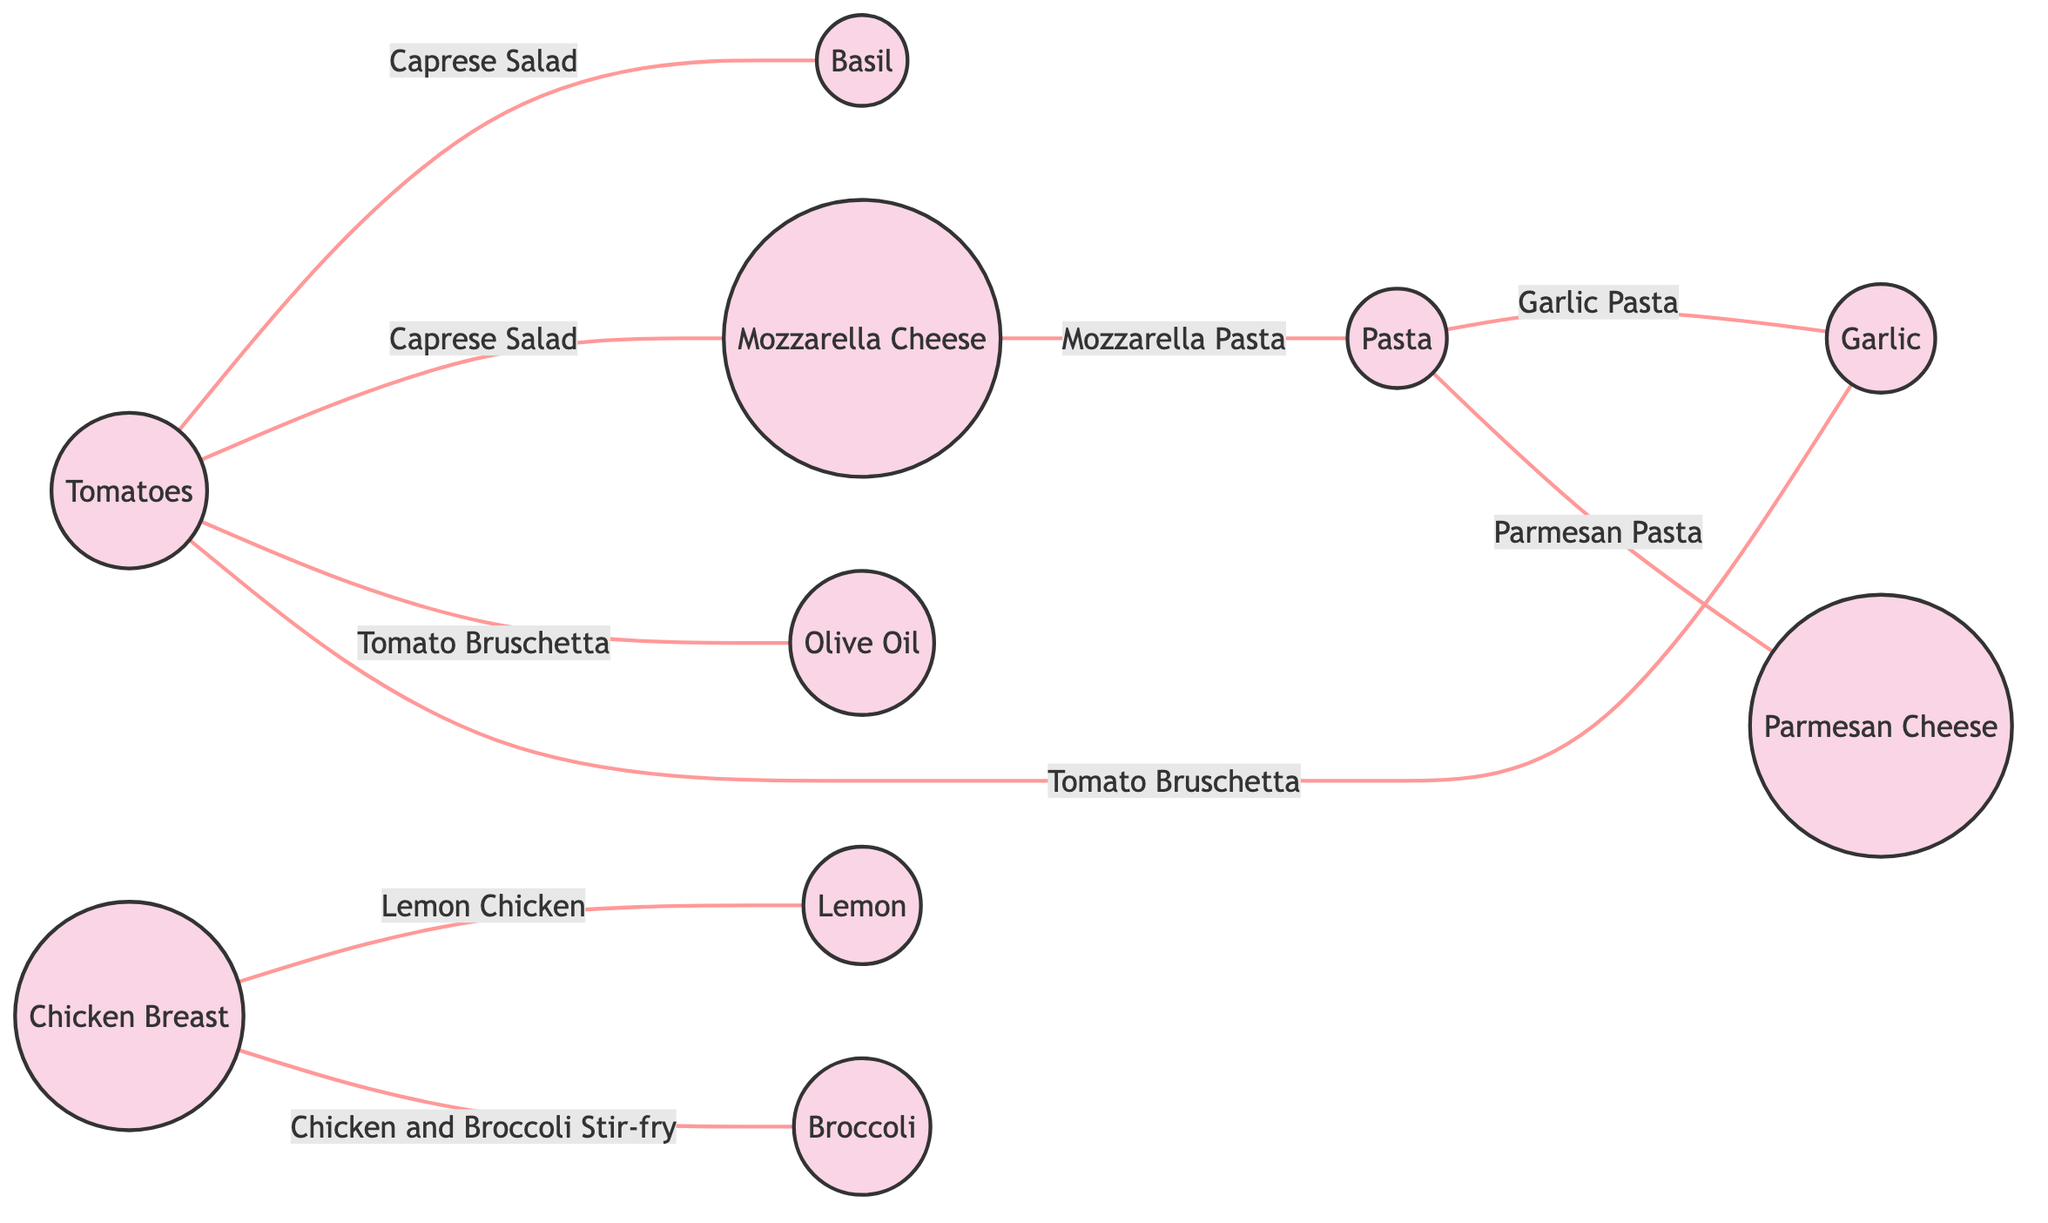What ingredient is used in both Caprese Salad and Tomato Bruschetta? By examining the edges connected to the single ingredient nodes "Caprese Salad" and "Tomato Bruschetta," we can identify that "Tomatoes" is common in both dishes as it connects to both dish nodes.
Answer: Tomatoes How many dishes are listed in the diagram? The edges represent dishes, and counting them reveals there are a total of 8 edges (dishes) in the diagram connecting various ingredient nodes.
Answer: 8 What are the ingredients used in Lemon Chicken? The edge labeled "Lemon Chicken" connects the node "Chicken Breast" to the node "Lemon." Therefore, the ingredients used in Lemon Chicken are "Chicken Breast" and "Lemon."
Answer: Chicken Breast, Lemon Which ingredient connects to the most dishes? By counting the edges for each ingredient, "Tomatoes" connects to 4 dishes (Caprese Salad and Tomato Bruschetta). The highest count across all ingredients is observed for “Tomatoes.”
Answer: Tomatoes What is the relationship between Mozzarella Cheese and Pasta? The edge labeled "Mozzarella Pasta" shows a direct connection between "Mozzarella Cheese" and "Pasta," indicating that Mozzarella Cheese is used in a dish named Mozzarella Pasta that includes Pasta as a component.
Answer: Mozzarella Pasta Which two ingredients are combined for Garlic Pasta? The edge "Garlic Pasta" connects node "Pasta" and node "Garlic." Thus, the two ingredients that are combined for Garlic Pasta are "Pasta" and "Garlic."
Answer: Pasta, Garlic What is the label of the edge connecting Tomatoes and Basil? The edge that connects "Tomatoes" to "Basil" is labeled "Caprese Salad," indicating the relationship or dish that utilizes these two ingredients together.
Answer: Caprese Salad How many ingredients are connected to Chicken Breast? By observing the edges from "Chicken Breast," it connects to two ingredients: "Lemon" and "Broccoli" through the dishes "Lemon Chicken" and "Chicken and Broccoli Stir-fry," which totals to two connections.
Answer: 2 